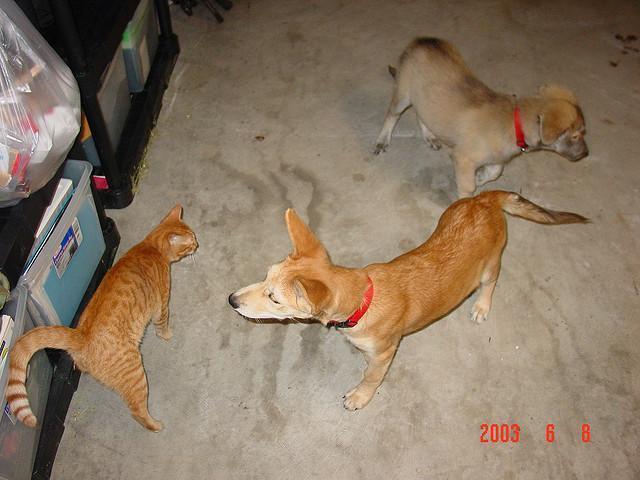How many dogs do you see?
Give a very brief answer. 2. How many cats are there?
Give a very brief answer. 1. How many dogs are actually there?
Give a very brief answer. 2. How many dogs are there?
Give a very brief answer. 2. How many bears are there?
Give a very brief answer. 0. 